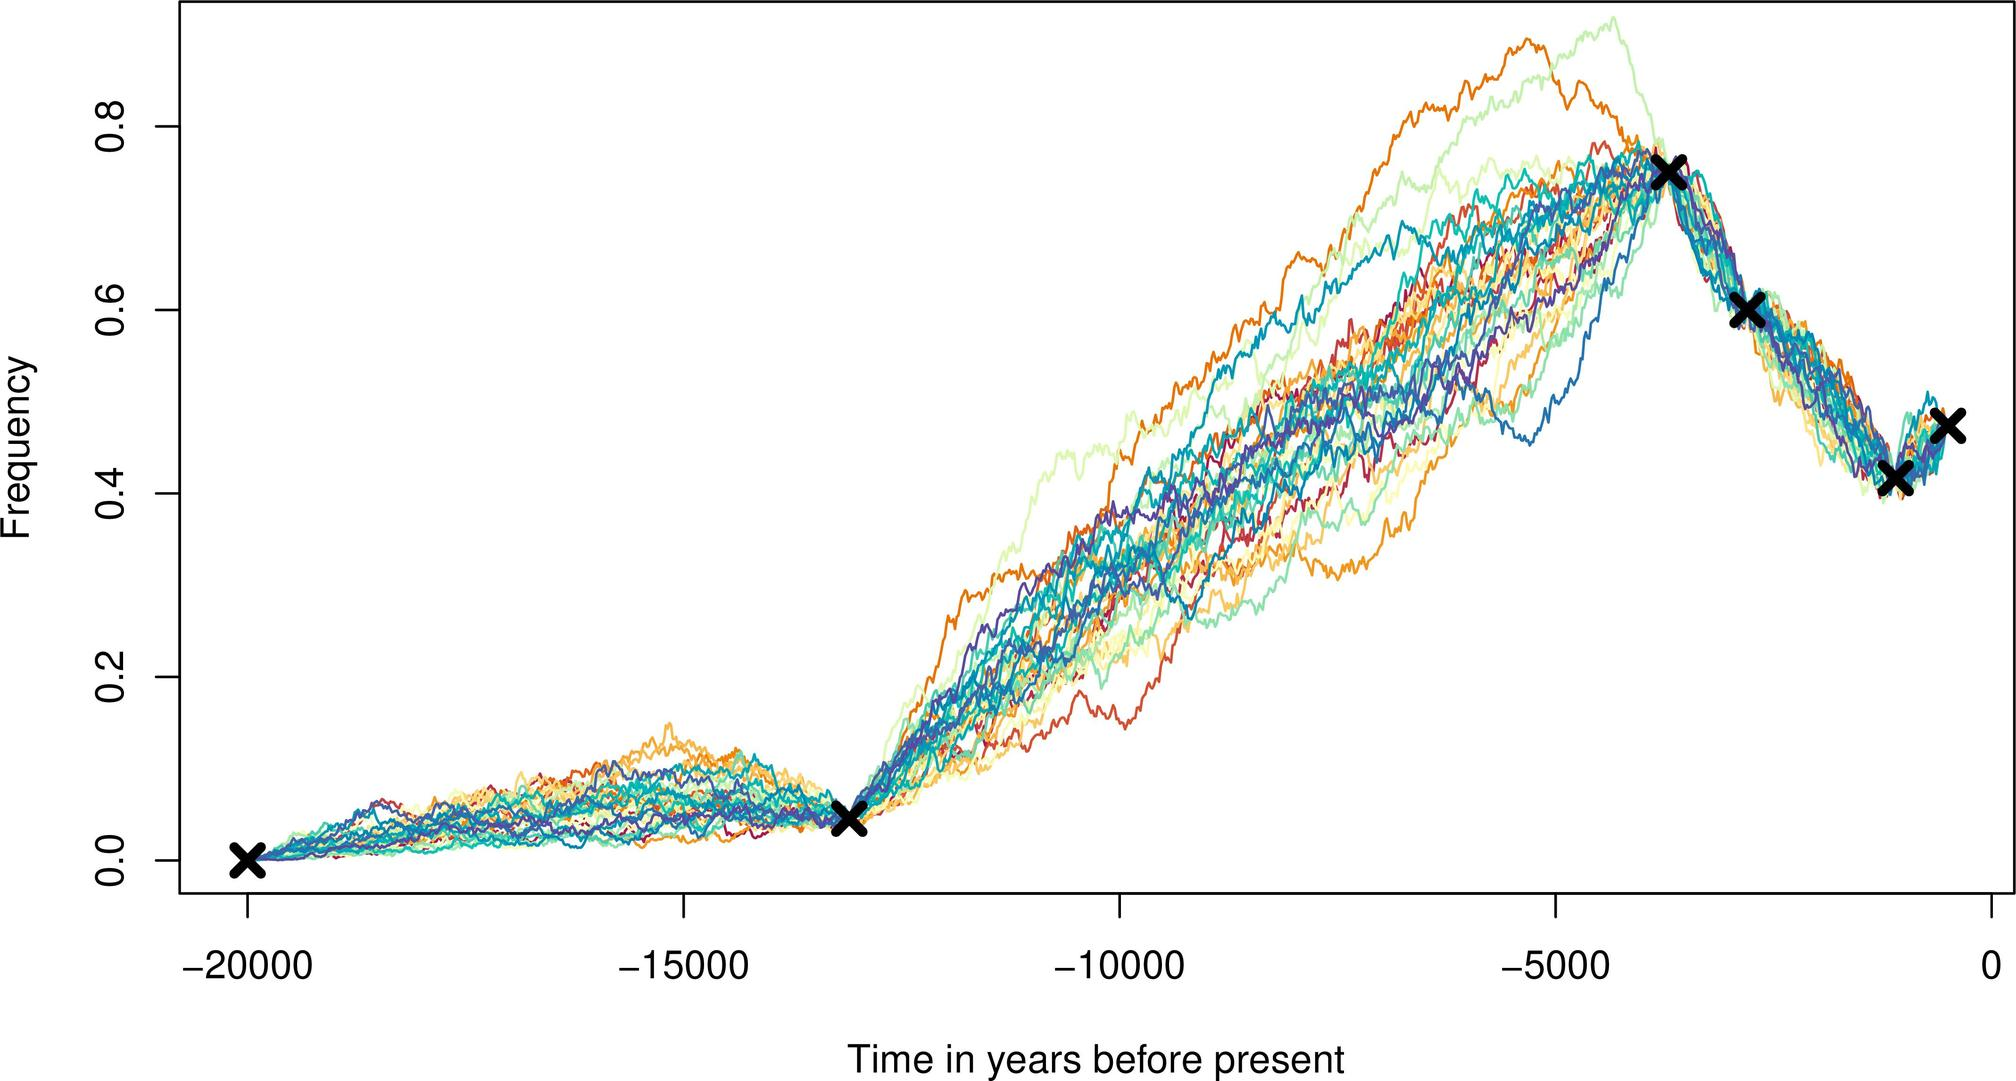What does the clustering of crosses towards the right end of the graph suggest? A convergence of data towards a common event or time period. Anomalies in the data sets. Random placement of data markers. Discrepancies between the data sets. The concentration of crosses at the right end of the graph points to a convergence of data, indicating that multiple observations or measurements are aligning around a common event or time period. This pattern could suggest a significant historical or natural occurrence that has been consistently recorded across different data sets. Although there may be variations in the specifics of each data set, the general trend appears to be in agreement, underscoring the potential relevance of this convergence. It is worth noting that further analysis would be necessary to determine the exact nature of the event and to rule out any anomalies or discrepancies. 